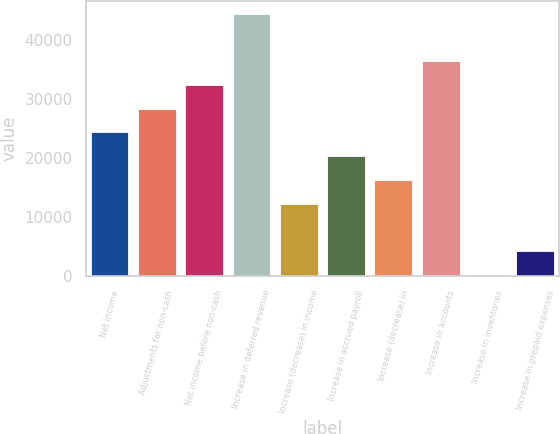Convert chart to OTSL. <chart><loc_0><loc_0><loc_500><loc_500><bar_chart><fcel>Net income<fcel>Adjustments for non-cash<fcel>Net income before non-cash<fcel>Increase in deferred revenue<fcel>Increase (decrease) in income<fcel>Increase in accrued payroll<fcel>Increase (decrease) in<fcel>Increase in accounts<fcel>Increase in inventories<fcel>Increase in prepaid expenses<nl><fcel>24293.4<fcel>28310.8<fcel>32328.2<fcel>44380.4<fcel>12241.2<fcel>20276<fcel>16258.6<fcel>36345.6<fcel>189<fcel>4206.4<nl></chart> 